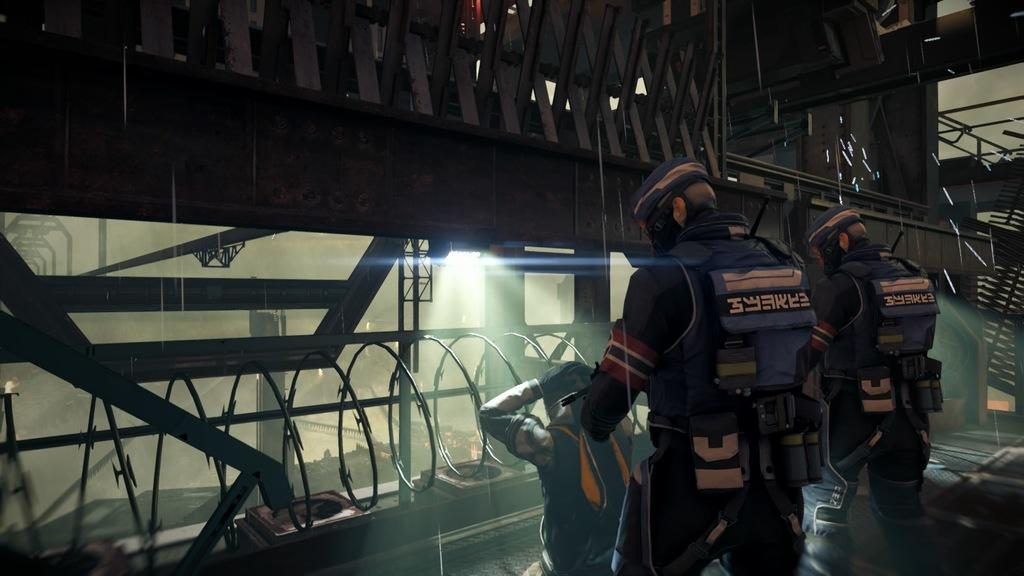How many people are present in the image? There are three persons in the image. What objects can be seen in the image besides the people? There are iron rods in the image. Can you describe any other objects present in the image? There are other objects in the image, but their specific details are not mentioned in the provided facts. What type of orange can be seen in the office in the image? There is no orange or office present in the image; it only mentions three persons and iron rods. 